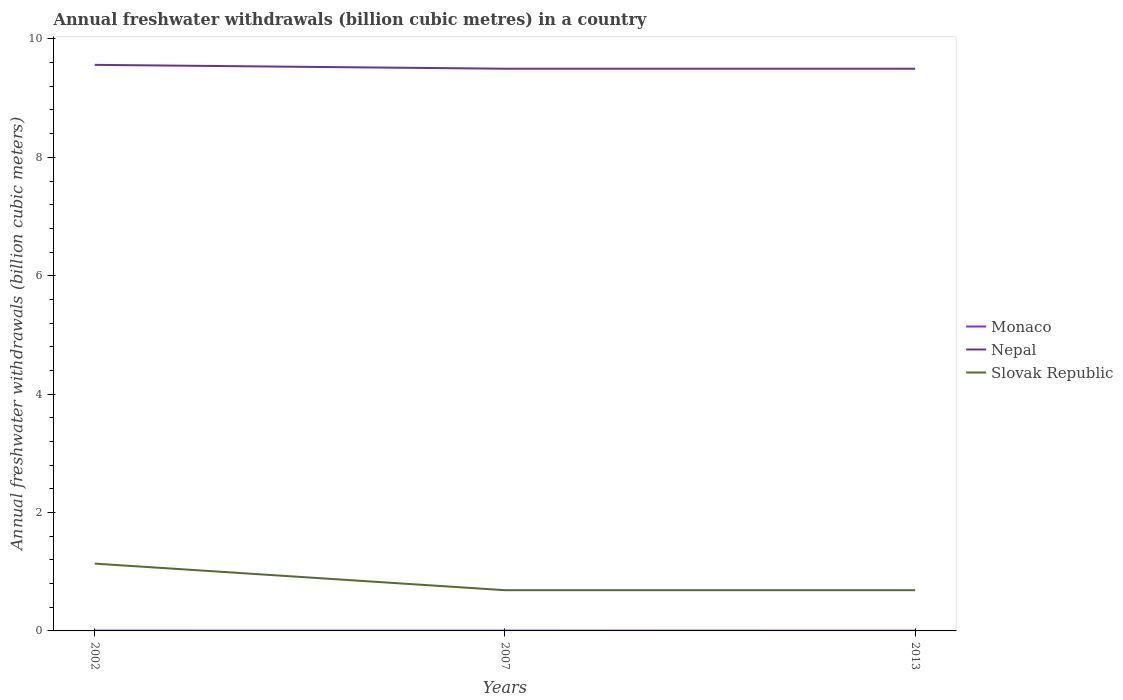How many different coloured lines are there?
Provide a succinct answer. 3. Across all years, what is the maximum annual freshwater withdrawals in Nepal?
Your response must be concise. 9.5. In which year was the annual freshwater withdrawals in Nepal maximum?
Provide a short and direct response. 2007. What is the total annual freshwater withdrawals in Nepal in the graph?
Make the answer very short. 0. What is the difference between the highest and the second highest annual freshwater withdrawals in Nepal?
Give a very brief answer. 0.06. What is the difference between the highest and the lowest annual freshwater withdrawals in Slovak Republic?
Your answer should be compact. 1. How many lines are there?
Your response must be concise. 3. What is the difference between two consecutive major ticks on the Y-axis?
Offer a terse response. 2. Does the graph contain any zero values?
Your response must be concise. No. Where does the legend appear in the graph?
Provide a succinct answer. Center right. What is the title of the graph?
Keep it short and to the point. Annual freshwater withdrawals (billion cubic metres) in a country. Does "Ghana" appear as one of the legend labels in the graph?
Give a very brief answer. No. What is the label or title of the X-axis?
Provide a succinct answer. Years. What is the label or title of the Y-axis?
Keep it short and to the point. Annual freshwater withdrawals (billion cubic meters). What is the Annual freshwater withdrawals (billion cubic meters) of Monaco in 2002?
Provide a succinct answer. 0.01. What is the Annual freshwater withdrawals (billion cubic meters) in Nepal in 2002?
Provide a short and direct response. 9.56. What is the Annual freshwater withdrawals (billion cubic meters) in Slovak Republic in 2002?
Offer a very short reply. 1.14. What is the Annual freshwater withdrawals (billion cubic meters) of Monaco in 2007?
Keep it short and to the point. 0.01. What is the Annual freshwater withdrawals (billion cubic meters) in Nepal in 2007?
Provide a succinct answer. 9.5. What is the Annual freshwater withdrawals (billion cubic meters) in Slovak Republic in 2007?
Give a very brief answer. 0.69. What is the Annual freshwater withdrawals (billion cubic meters) in Monaco in 2013?
Provide a succinct answer. 0.01. What is the Annual freshwater withdrawals (billion cubic meters) in Nepal in 2013?
Keep it short and to the point. 9.5. What is the Annual freshwater withdrawals (billion cubic meters) in Slovak Republic in 2013?
Your answer should be very brief. 0.69. Across all years, what is the maximum Annual freshwater withdrawals (billion cubic meters) in Monaco?
Offer a very short reply. 0.01. Across all years, what is the maximum Annual freshwater withdrawals (billion cubic meters) in Nepal?
Your answer should be compact. 9.56. Across all years, what is the maximum Annual freshwater withdrawals (billion cubic meters) in Slovak Republic?
Make the answer very short. 1.14. Across all years, what is the minimum Annual freshwater withdrawals (billion cubic meters) of Monaco?
Your answer should be compact. 0.01. Across all years, what is the minimum Annual freshwater withdrawals (billion cubic meters) in Nepal?
Provide a short and direct response. 9.5. Across all years, what is the minimum Annual freshwater withdrawals (billion cubic meters) of Slovak Republic?
Ensure brevity in your answer.  0.69. What is the total Annual freshwater withdrawals (billion cubic meters) of Monaco in the graph?
Your response must be concise. 0.02. What is the total Annual freshwater withdrawals (billion cubic meters) of Nepal in the graph?
Give a very brief answer. 28.56. What is the total Annual freshwater withdrawals (billion cubic meters) of Slovak Republic in the graph?
Your answer should be very brief. 2.51. What is the difference between the Annual freshwater withdrawals (billion cubic meters) of Monaco in 2002 and that in 2007?
Your response must be concise. 0. What is the difference between the Annual freshwater withdrawals (billion cubic meters) in Nepal in 2002 and that in 2007?
Offer a very short reply. 0.07. What is the difference between the Annual freshwater withdrawals (billion cubic meters) in Slovak Republic in 2002 and that in 2007?
Your answer should be compact. 0.45. What is the difference between the Annual freshwater withdrawals (billion cubic meters) of Monaco in 2002 and that in 2013?
Provide a succinct answer. 0. What is the difference between the Annual freshwater withdrawals (billion cubic meters) of Nepal in 2002 and that in 2013?
Make the answer very short. 0.07. What is the difference between the Annual freshwater withdrawals (billion cubic meters) of Slovak Republic in 2002 and that in 2013?
Ensure brevity in your answer.  0.45. What is the difference between the Annual freshwater withdrawals (billion cubic meters) in Monaco in 2007 and that in 2013?
Make the answer very short. 0. What is the difference between the Annual freshwater withdrawals (billion cubic meters) in Slovak Republic in 2007 and that in 2013?
Offer a very short reply. 0. What is the difference between the Annual freshwater withdrawals (billion cubic meters) in Monaco in 2002 and the Annual freshwater withdrawals (billion cubic meters) in Nepal in 2007?
Offer a very short reply. -9.49. What is the difference between the Annual freshwater withdrawals (billion cubic meters) of Monaco in 2002 and the Annual freshwater withdrawals (billion cubic meters) of Slovak Republic in 2007?
Your answer should be very brief. -0.68. What is the difference between the Annual freshwater withdrawals (billion cubic meters) in Nepal in 2002 and the Annual freshwater withdrawals (billion cubic meters) in Slovak Republic in 2007?
Provide a succinct answer. 8.87. What is the difference between the Annual freshwater withdrawals (billion cubic meters) in Monaco in 2002 and the Annual freshwater withdrawals (billion cubic meters) in Nepal in 2013?
Provide a short and direct response. -9.49. What is the difference between the Annual freshwater withdrawals (billion cubic meters) of Monaco in 2002 and the Annual freshwater withdrawals (billion cubic meters) of Slovak Republic in 2013?
Keep it short and to the point. -0.68. What is the difference between the Annual freshwater withdrawals (billion cubic meters) of Nepal in 2002 and the Annual freshwater withdrawals (billion cubic meters) of Slovak Republic in 2013?
Make the answer very short. 8.87. What is the difference between the Annual freshwater withdrawals (billion cubic meters) of Monaco in 2007 and the Annual freshwater withdrawals (billion cubic meters) of Nepal in 2013?
Give a very brief answer. -9.49. What is the difference between the Annual freshwater withdrawals (billion cubic meters) in Monaco in 2007 and the Annual freshwater withdrawals (billion cubic meters) in Slovak Republic in 2013?
Offer a terse response. -0.68. What is the difference between the Annual freshwater withdrawals (billion cubic meters) in Nepal in 2007 and the Annual freshwater withdrawals (billion cubic meters) in Slovak Republic in 2013?
Your answer should be compact. 8.81. What is the average Annual freshwater withdrawals (billion cubic meters) of Monaco per year?
Ensure brevity in your answer.  0.01. What is the average Annual freshwater withdrawals (billion cubic meters) in Nepal per year?
Keep it short and to the point. 9.52. What is the average Annual freshwater withdrawals (billion cubic meters) of Slovak Republic per year?
Keep it short and to the point. 0.84. In the year 2002, what is the difference between the Annual freshwater withdrawals (billion cubic meters) of Monaco and Annual freshwater withdrawals (billion cubic meters) of Nepal?
Offer a very short reply. -9.56. In the year 2002, what is the difference between the Annual freshwater withdrawals (billion cubic meters) of Monaco and Annual freshwater withdrawals (billion cubic meters) of Slovak Republic?
Give a very brief answer. -1.13. In the year 2002, what is the difference between the Annual freshwater withdrawals (billion cubic meters) in Nepal and Annual freshwater withdrawals (billion cubic meters) in Slovak Republic?
Ensure brevity in your answer.  8.43. In the year 2007, what is the difference between the Annual freshwater withdrawals (billion cubic meters) of Monaco and Annual freshwater withdrawals (billion cubic meters) of Nepal?
Make the answer very short. -9.49. In the year 2007, what is the difference between the Annual freshwater withdrawals (billion cubic meters) in Monaco and Annual freshwater withdrawals (billion cubic meters) in Slovak Republic?
Your answer should be very brief. -0.68. In the year 2007, what is the difference between the Annual freshwater withdrawals (billion cubic meters) in Nepal and Annual freshwater withdrawals (billion cubic meters) in Slovak Republic?
Your answer should be very brief. 8.81. In the year 2013, what is the difference between the Annual freshwater withdrawals (billion cubic meters) of Monaco and Annual freshwater withdrawals (billion cubic meters) of Nepal?
Your response must be concise. -9.49. In the year 2013, what is the difference between the Annual freshwater withdrawals (billion cubic meters) in Monaco and Annual freshwater withdrawals (billion cubic meters) in Slovak Republic?
Offer a very short reply. -0.68. In the year 2013, what is the difference between the Annual freshwater withdrawals (billion cubic meters) in Nepal and Annual freshwater withdrawals (billion cubic meters) in Slovak Republic?
Keep it short and to the point. 8.81. What is the ratio of the Annual freshwater withdrawals (billion cubic meters) of Monaco in 2002 to that in 2007?
Offer a very short reply. 1.05. What is the ratio of the Annual freshwater withdrawals (billion cubic meters) in Nepal in 2002 to that in 2007?
Offer a very short reply. 1.01. What is the ratio of the Annual freshwater withdrawals (billion cubic meters) of Slovak Republic in 2002 to that in 2007?
Keep it short and to the point. 1.65. What is the ratio of the Annual freshwater withdrawals (billion cubic meters) in Monaco in 2002 to that in 2013?
Your answer should be compact. 1.16. What is the ratio of the Annual freshwater withdrawals (billion cubic meters) in Nepal in 2002 to that in 2013?
Provide a short and direct response. 1.01. What is the ratio of the Annual freshwater withdrawals (billion cubic meters) of Slovak Republic in 2002 to that in 2013?
Offer a terse response. 1.65. What is the ratio of the Annual freshwater withdrawals (billion cubic meters) of Monaco in 2007 to that in 2013?
Keep it short and to the point. 1.1. What is the difference between the highest and the second highest Annual freshwater withdrawals (billion cubic meters) in Nepal?
Provide a short and direct response. 0.07. What is the difference between the highest and the second highest Annual freshwater withdrawals (billion cubic meters) in Slovak Republic?
Make the answer very short. 0.45. What is the difference between the highest and the lowest Annual freshwater withdrawals (billion cubic meters) in Monaco?
Give a very brief answer. 0. What is the difference between the highest and the lowest Annual freshwater withdrawals (billion cubic meters) in Nepal?
Make the answer very short. 0.07. What is the difference between the highest and the lowest Annual freshwater withdrawals (billion cubic meters) of Slovak Republic?
Provide a short and direct response. 0.45. 